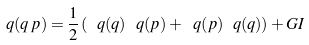Convert formula to latex. <formula><loc_0><loc_0><loc_500><loc_500>\ q ( q \, p ) = \frac { 1 } { 2 } \left ( \ q ( q ) \ q ( p ) + \ q ( p ) \ q ( q ) \right ) + G I</formula> 